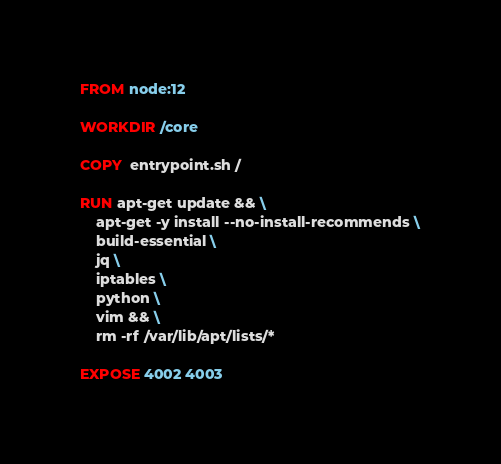Convert code to text. <code><loc_0><loc_0><loc_500><loc_500><_Dockerfile_>FROM node:12

WORKDIR /core

COPY  entrypoint.sh /

RUN apt-get update && \
    apt-get -y install --no-install-recommends \
    build-essential \
    jq \
    iptables \
    python \
    vim && \
    rm -rf /var/lib/apt/lists/*

EXPOSE 4002 4003
</code> 